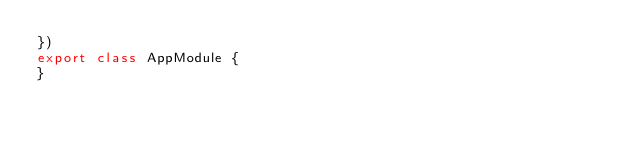Convert code to text. <code><loc_0><loc_0><loc_500><loc_500><_TypeScript_>})
export class AppModule {
}
</code> 